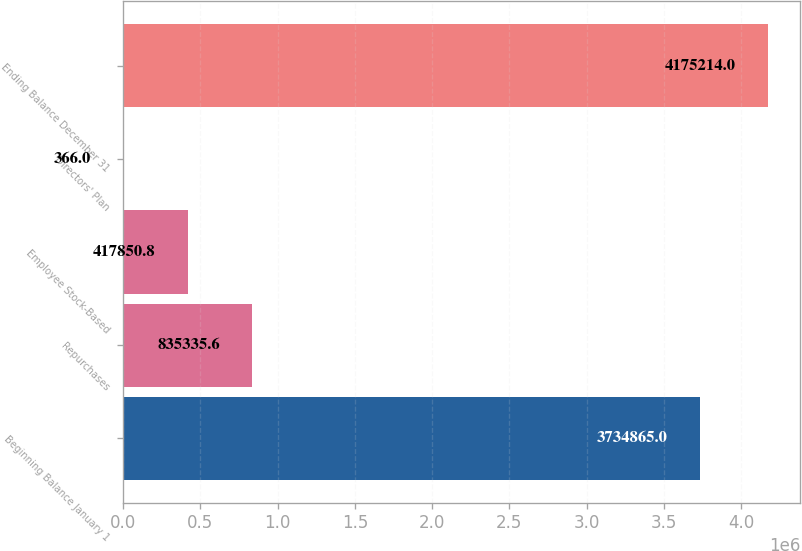<chart> <loc_0><loc_0><loc_500><loc_500><bar_chart><fcel>Beginning Balance January 1<fcel>Repurchases<fcel>Employee Stock-Based<fcel>Directors' Plan<fcel>Ending Balance December 31<nl><fcel>3.73486e+06<fcel>835336<fcel>417851<fcel>366<fcel>4.17521e+06<nl></chart> 